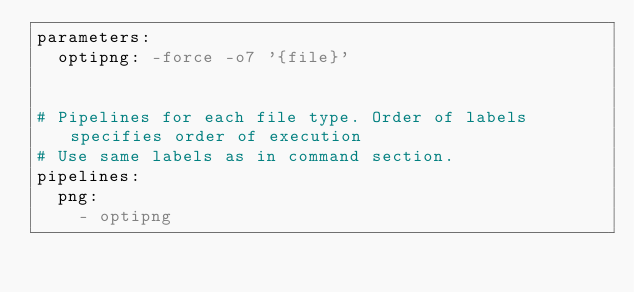<code> <loc_0><loc_0><loc_500><loc_500><_YAML_>parameters:
  optipng: -force -o7 '{file}'


# Pipelines for each file type. Order of labels specifies order of execution
# Use same labels as in command section.
pipelines:
  png:
    - optipng
</code> 